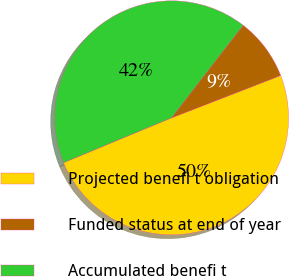Convert chart to OTSL. <chart><loc_0><loc_0><loc_500><loc_500><pie_chart><fcel>Projected benefi t obligation<fcel>Funded status at end of year<fcel>Accumulated benefi t<nl><fcel>49.63%<fcel>8.62%<fcel>41.75%<nl></chart> 